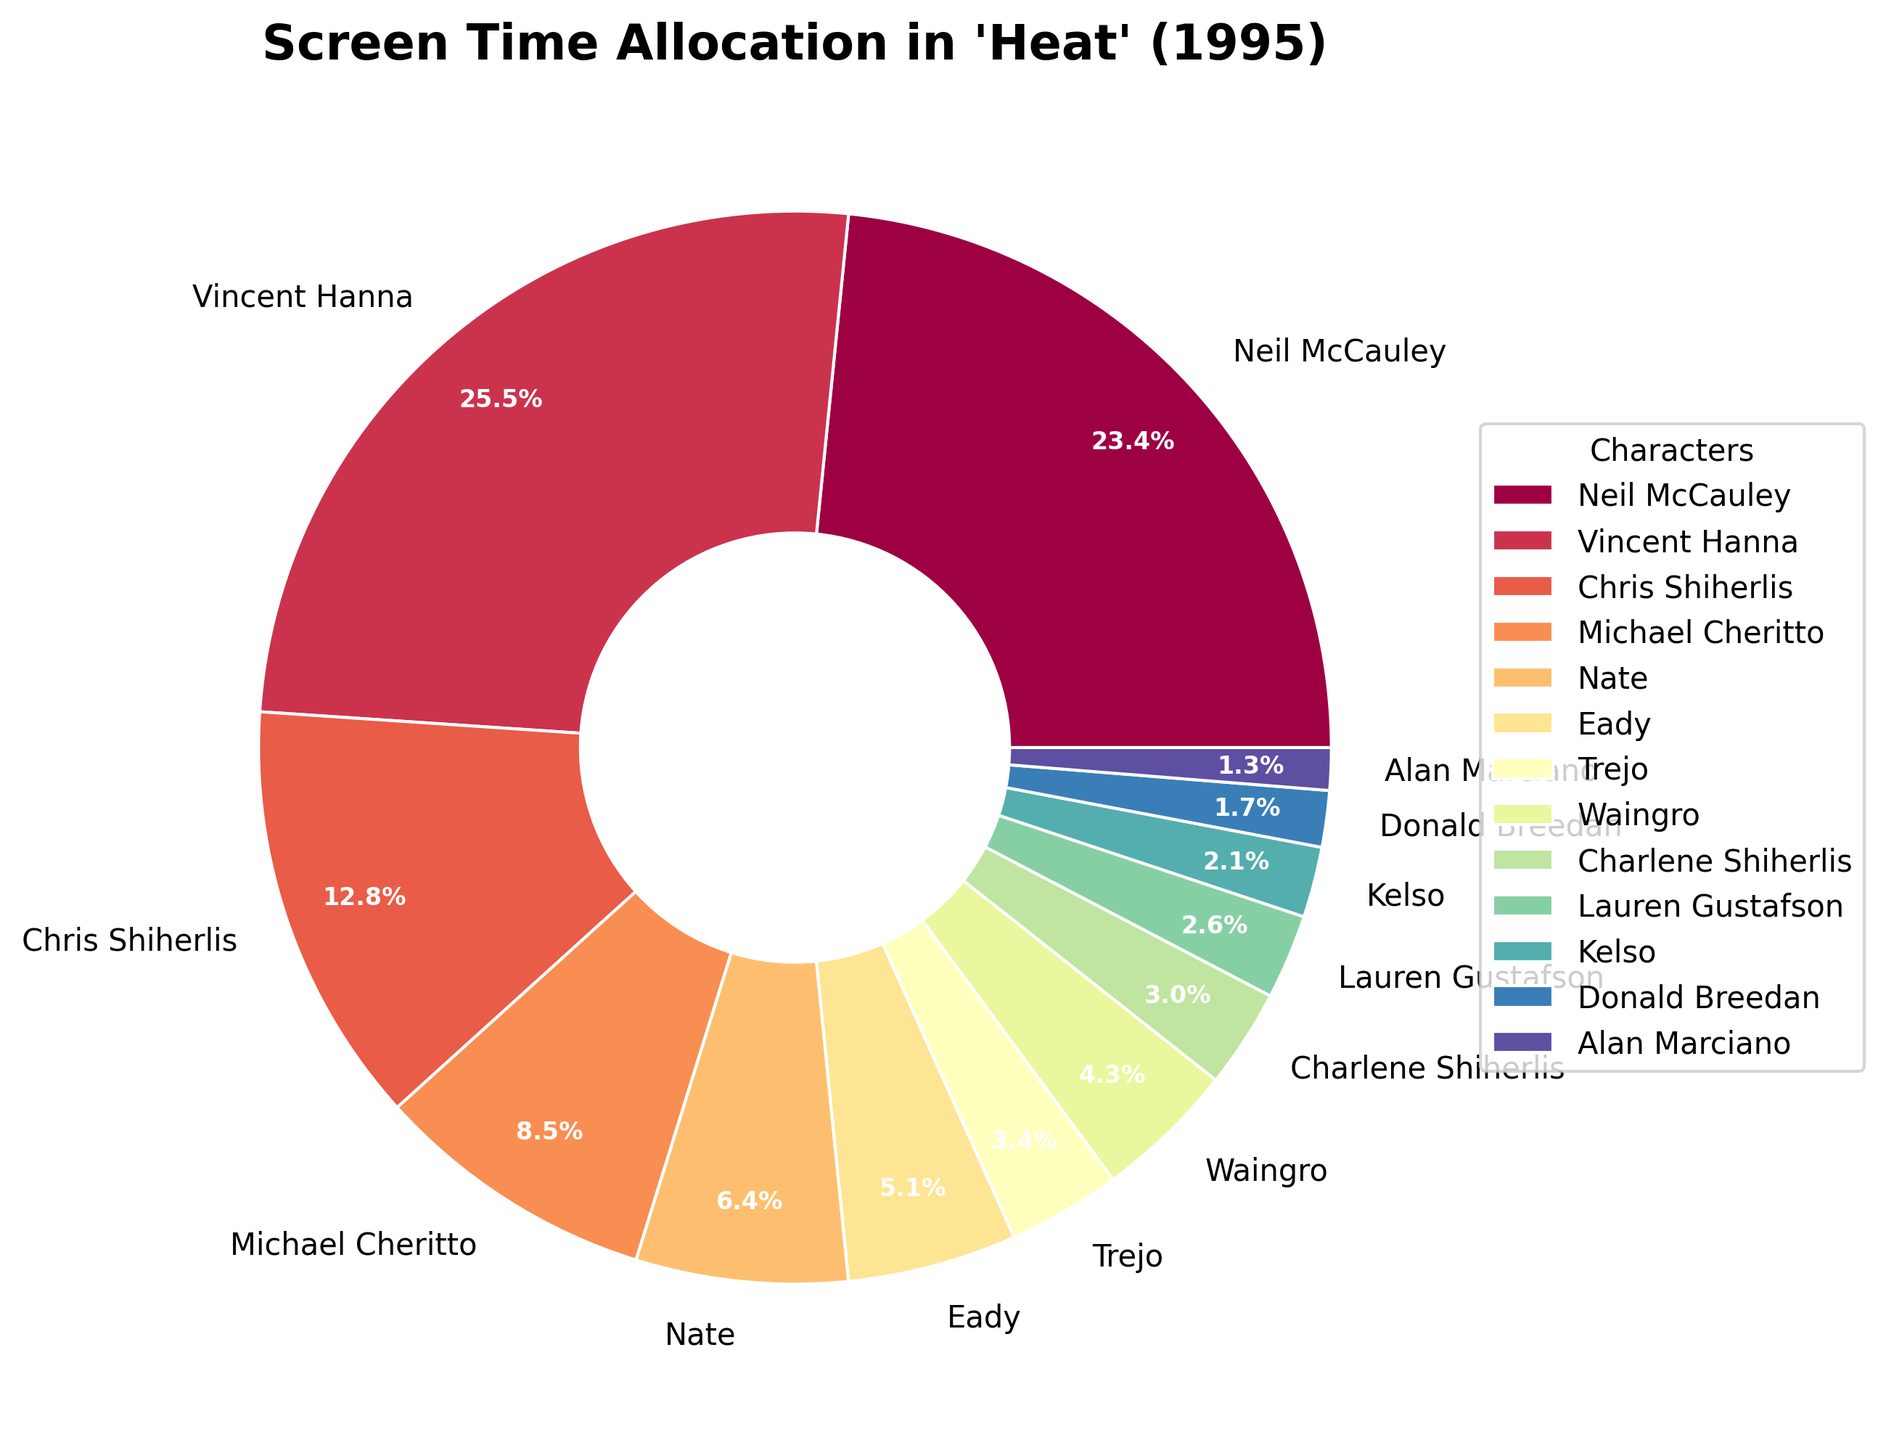Who has the most screen time in "Heat" (1995)? The figure shows the screen time distribution of characters. The character labeled with the largest percentage of the pie chart has the most screen time, which is Vincent Hanna. He has the most screen time according to the figure.
Answer: Vincent Hanna Which two characters together have more screen time, Neil McCauley and Chris Shiherlis or Vincent Hanna and Eady? First, identify the screen times for Neil McCauley (55 minutes) and Chris Shiherlis (30 minutes) which together equal 85 minutes. Then identify the screen times for Vincent Hanna (60 minutes) and Eady (12 minutes), which together equal 72 minutes. Comparing 85 minutes to 72 minutes, Neil McCauley and Chris Shiherlis have more screen time together.
Answer: Neil McCauley and Chris Shiherlis What percentage of the screen time is dedicated to the top three characters? Sum the screen times of Vincent Hanna (60 minutes), Neil McCauley (55 minutes), and Chris Shiherlis (30 minutes), which equals 145 minutes. Determine the total screen time by summing all characters' screen times (total of 235 minutes). Calculate the percentage: (145 / 235) * 100, which equals 61.7%.
Answer: 61.7% How does the screen time of Waingro compare to that of Trejo? Find the screen times of Waingro (10 minutes) and Trejo (8 minutes). Compare their times, noting that Waingro has 2 more minutes of screen time than Trejo.
Answer: Waingro has more screen time than Trejo What is the combined screen time of all characters who have less than 10 minutes of screen time each? Identify characters with screen times less than 10 minutes: Trejo (8), Charlene Shiherlis (7), Lauren Gustafson (6), Kelso (5), Donald Breedan (4), and Alan Marciano (3). Sum these times: 8 + 7 + 6 + 5 + 4 + 3 equals 33.
Answer: 33 minutes Which character has possibly the smallest percentage of the pie chart? Look for the character with the smallest slice in the pie chart. The visual inspection shows Alan Marciano appears to have the smallest percentage.
Answer: Alan Marciano Are Vincent Hanna and Neil McCauley's screen times combined greater than the screen times of all other characters combined? Find the screen times of Vincent Hanna (60 minutes) and Neil McCauley (55 minutes), which together equal 115 minutes. Sum all other characters' screen times: 175 - 60 - 55 equals 120 minutes. Compare 115 minutes with 120 minutes, noting that 'others' have more combined screen time.
Answer: No 